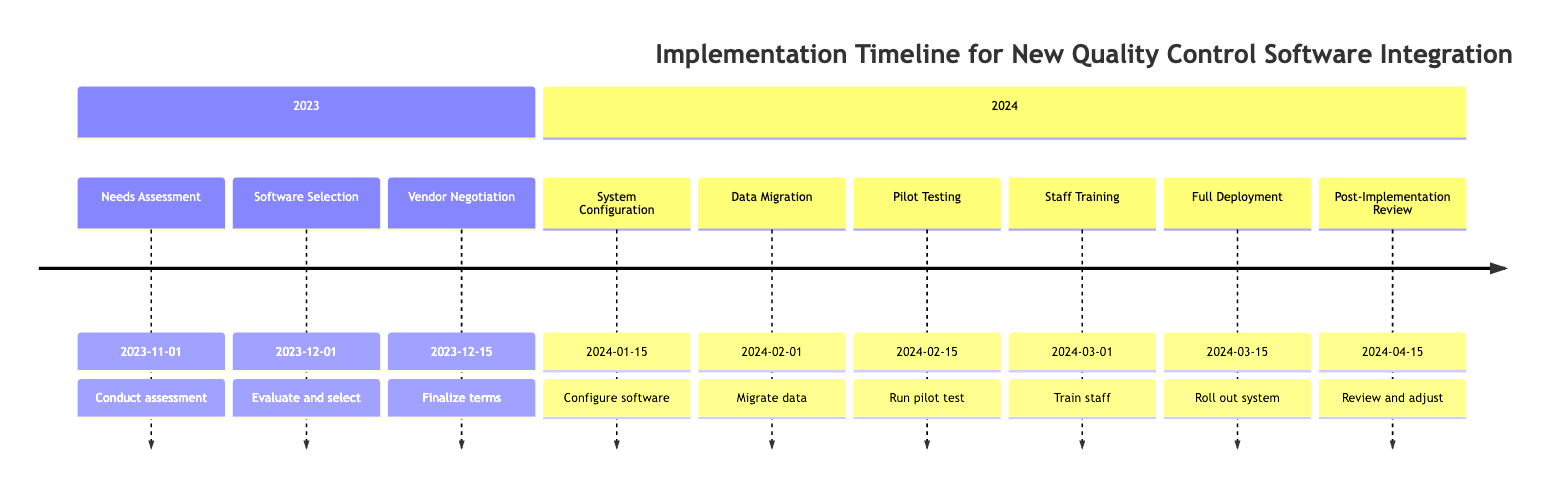What is the deadline for Needs Assessment? The deadline for the "Needs Assessment" milestone is on the timeline labeled "2023-11-01". This date is directly stated next to the "Needs Assessment" node in the timeline.
Answer: 2023-11-01 Which milestone comes after Data Migration? Looking at the timeline, the "Data Migration" milestone has a deadline of "2024-02-01", and directly following it is the "Pilot Testing" milestone, which occurs on "2024-02-15".
Answer: Pilot Testing How many milestones are there in total? By counting all the milestones listed in the timeline, there are 9 distinct milestones: Needs Assessment, Software Selection, Vendor Negotiation, System Configuration, Data Migration, Pilot Testing, Staff Training, Full Deployment, and Post-Implementation Review.
Answer: 9 What is the final deadline mentioned in the timeline? The last milestone in the timeline is "Post-Implementation Review" with a deadline of "2024-04-15". This is the furthest date listed in the timeline.
Answer: 2024-04-15 Which milestone is the first one to take place in 2024? The earliest milestone occurring in 2024 is "System Configuration", which is scheduled for "2024-01-15". This is the first milestone following the deadlines in 2023.
Answer: System Configuration What is the purpose of Staff Training? The "Staff Training" milestone's purpose is to "Conduct comprehensive training sessions for staff to ensure proficient use of the new quality control software." This information is found directly under the milestone in the timeline annotations.
Answer: Conduct training sessions When will full deployment take place? Referring to the timeline, the "Full Deployment" milestone is scheduled for "2024-03-15". This is the date set for rolling out the new quality control system across the entire site.
Answer: 2024-03-15 What happens after Full Deployment? Following the "Full Deployment" milestone, the next event is the "Post-Implementation Review", which takes place on "2024-04-15". This shows the continuation of the process after the deployment.
Answer: Post-Implementation Review What is the description associated with Vendor Negotiation? The description for the "Vendor Negotiation" milestone is "Finalize terms, negotiate pricing, and sign contracts with the selected software vendor." This provides clarity on what actions are taken during this milestone.
Answer: Finalize terms, negotiate pricing, and sign contracts 